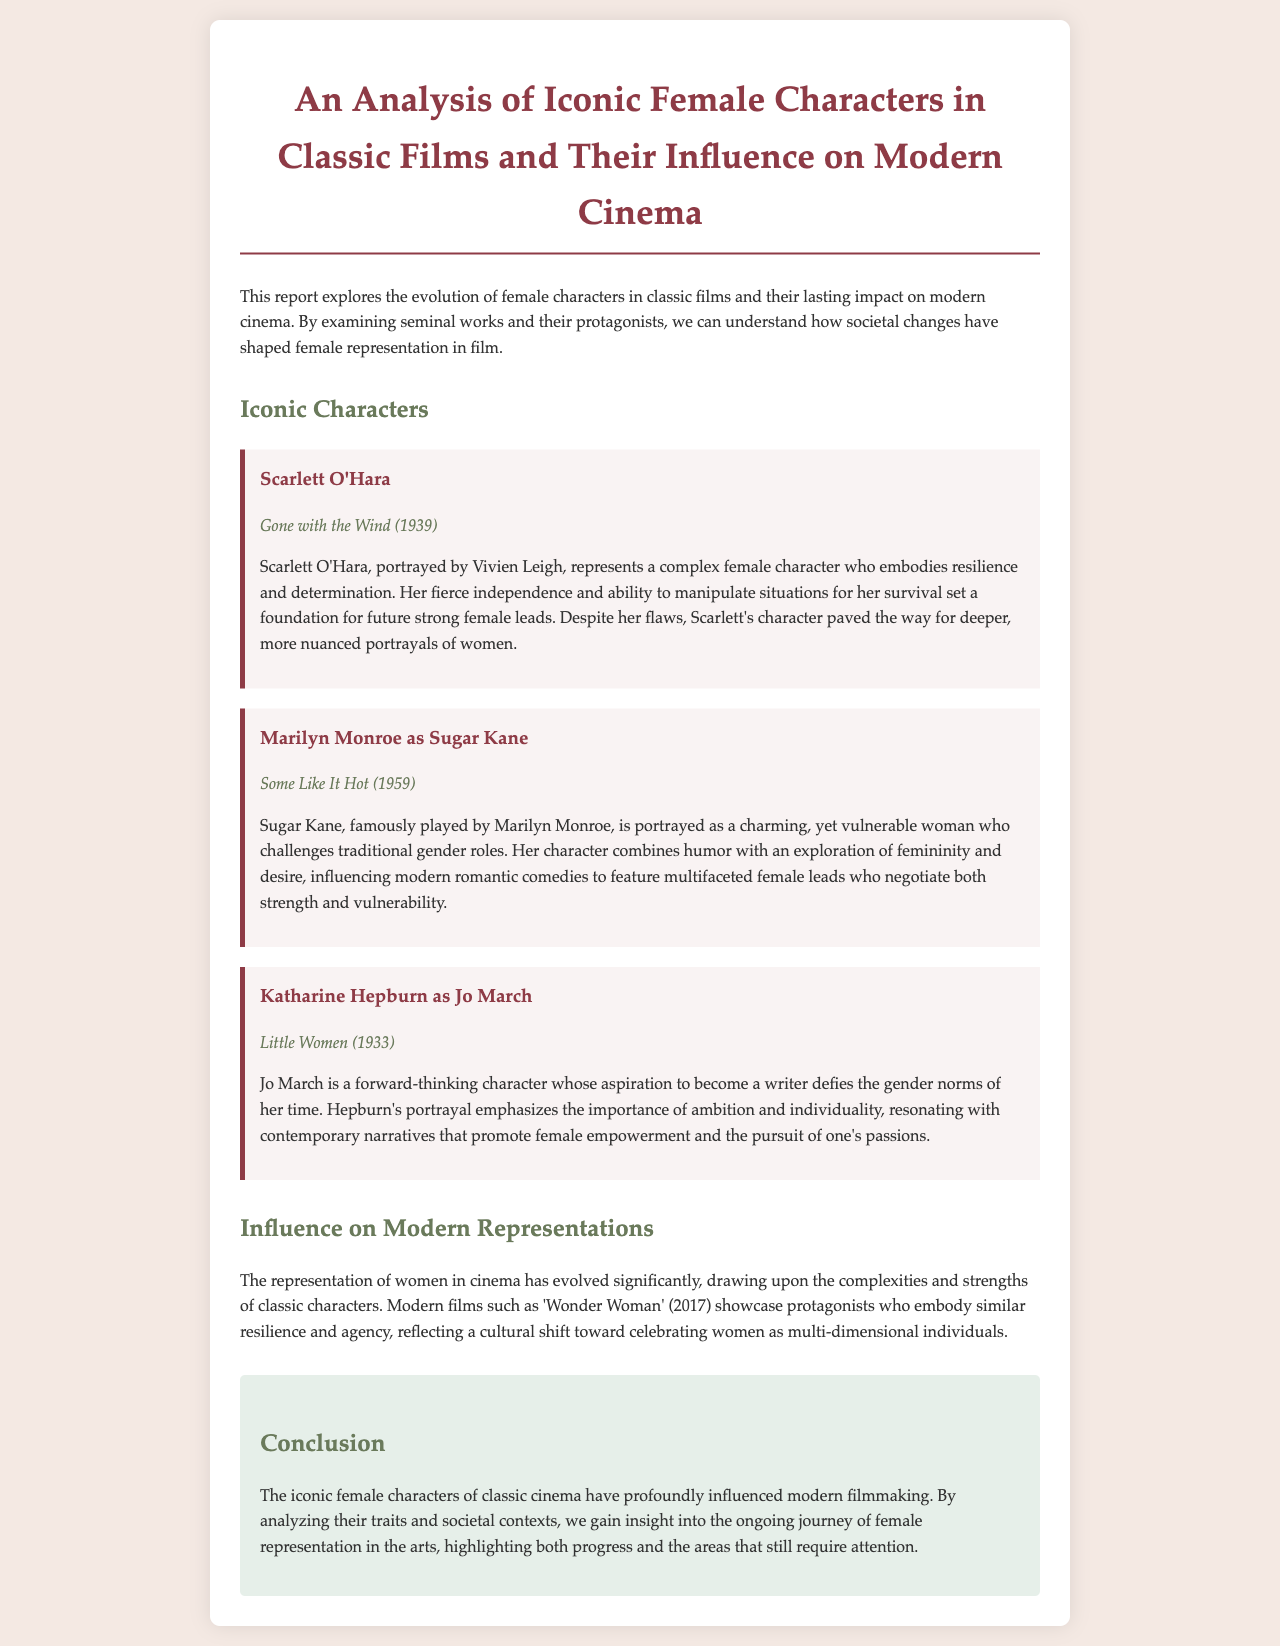what is the title of the report? The title of the report is mentioned at the beginning of the document, highlighting its focus on iconic female characters and their influence on modern cinema.
Answer: An Analysis of Iconic Female Characters in Classic Films and Their Influence on Modern Cinema who played Scarlett O'Hara? The document specifies that Scarlett O'Hara was portrayed by Vivien Leigh, providing her name in the context of the analysis.
Answer: Vivien Leigh what film features Sugar Kane? The film featuring Sugar Kane is indicated in the section about Marilyn Monroe's character, specifically mentioning it alongside her portrayal.
Answer: Some Like It Hot which character defies gender norms? The analysis discusses Jo March, who aspires to become a writer, defying the traditional gender norms of her time.
Answer: Jo March in what year was Little Women released? The document provides the release year of the film featuring Jo March, indicating it is key to understanding the character's context.
Answer: 1933 how does modern cinema reflect classic characters? The text explains that modern films showcase protagonists embodying resilience and agency, similar to classic female characters, making a direct connection to cultural shifts.
Answer: Celebrating women as multi-dimensional individuals what is one main trait attributed to Scarlett O'Hara? The report highlights that resilience is a key trait attributed to Scarlett O'Hara, characterizing her influence on future portrayals.
Answer: Resilience what conclusion is drawn about female representation? The conclusion emphasizes the ongoing journey and the areas that still require attention in female representation within the arts, summarizing its overall significance.
Answer: Progress and areas that still require attention 